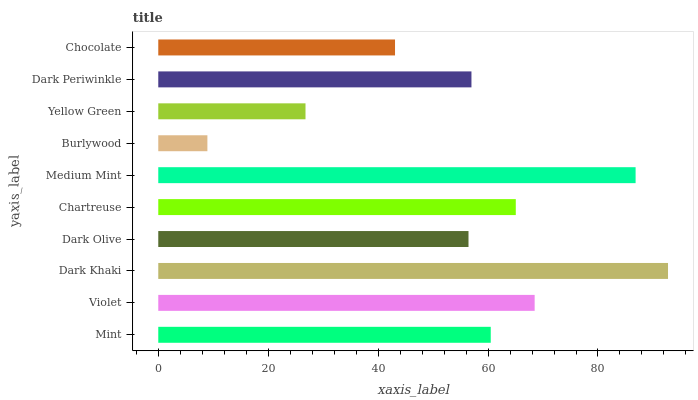Is Burlywood the minimum?
Answer yes or no. Yes. Is Dark Khaki the maximum?
Answer yes or no. Yes. Is Violet the minimum?
Answer yes or no. No. Is Violet the maximum?
Answer yes or no. No. Is Violet greater than Mint?
Answer yes or no. Yes. Is Mint less than Violet?
Answer yes or no. Yes. Is Mint greater than Violet?
Answer yes or no. No. Is Violet less than Mint?
Answer yes or no. No. Is Mint the high median?
Answer yes or no. Yes. Is Dark Periwinkle the low median?
Answer yes or no. Yes. Is Violet the high median?
Answer yes or no. No. Is Chartreuse the low median?
Answer yes or no. No. 